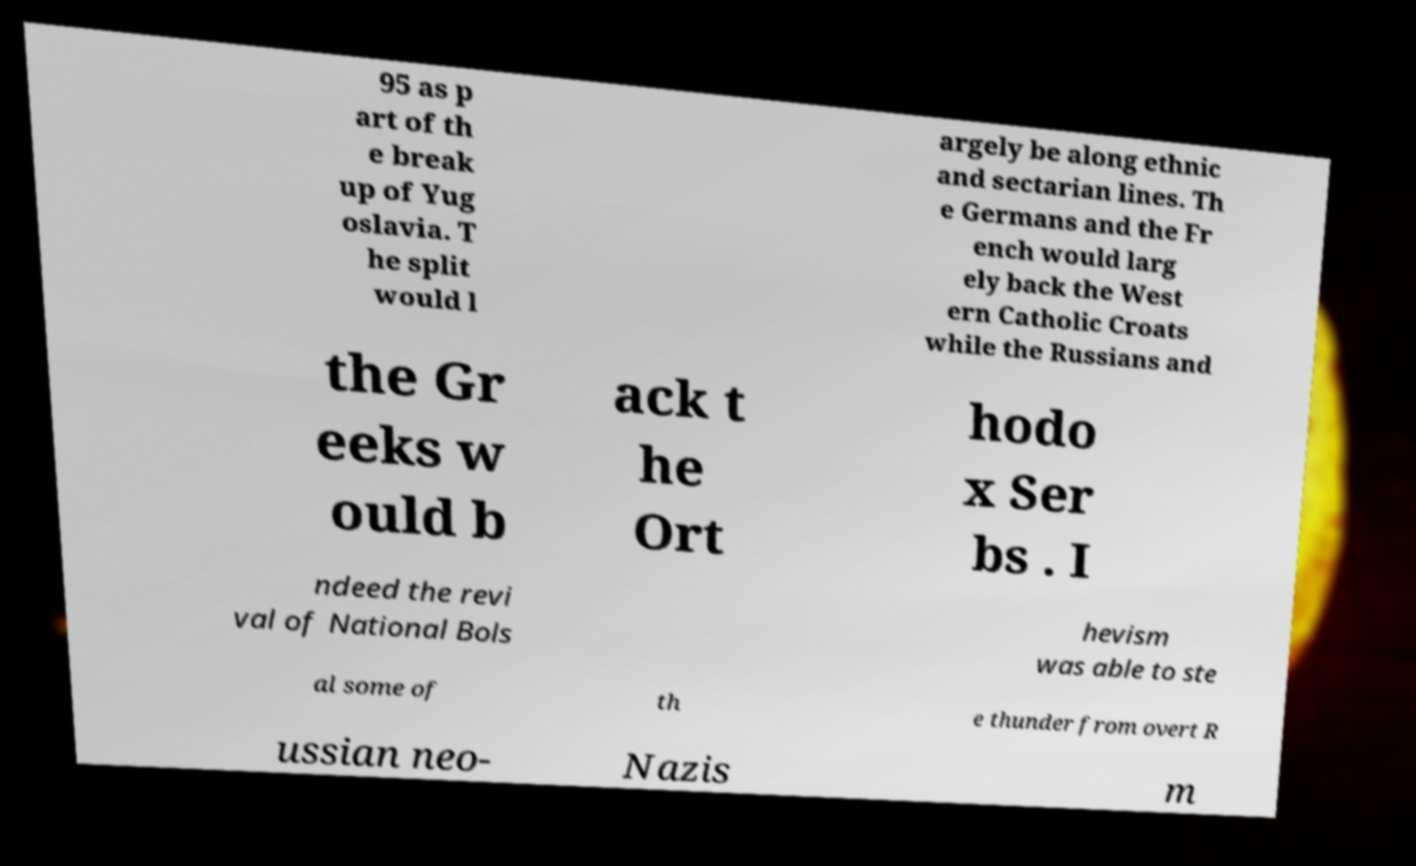Please identify and transcribe the text found in this image. 95 as p art of th e break up of Yug oslavia. T he split would l argely be along ethnic and sectarian lines. Th e Germans and the Fr ench would larg ely back the West ern Catholic Croats while the Russians and the Gr eeks w ould b ack t he Ort hodo x Ser bs . I ndeed the revi val of National Bols hevism was able to ste al some of th e thunder from overt R ussian neo- Nazis m 